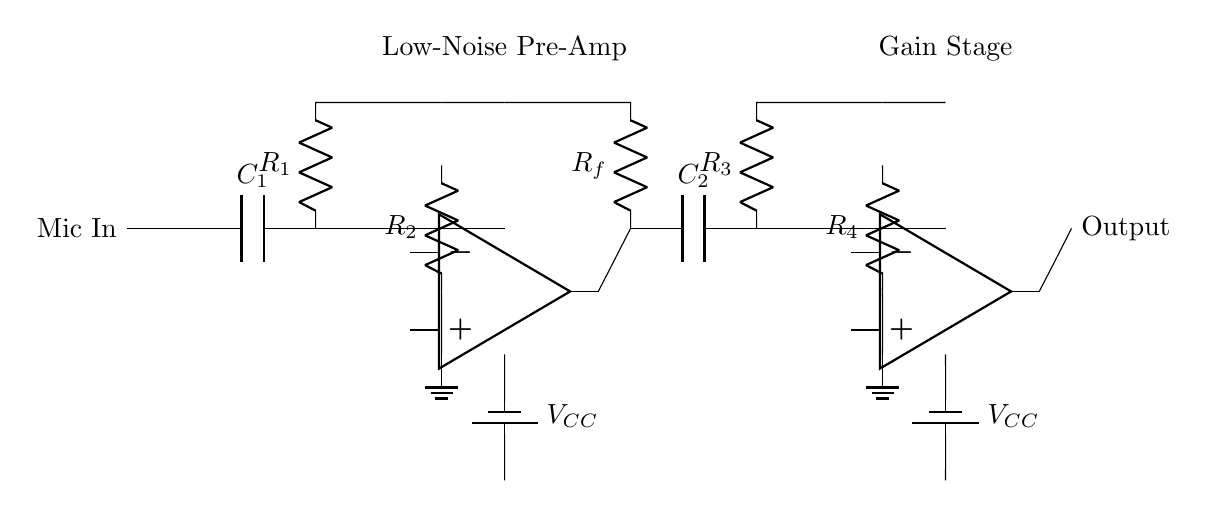What is the input component of the circuit? The input component of the circuit is a microphone, labeled "Mic In". It is the first part through which the audio signal enters the pre-amplifier circuit.
Answer: Microphone How many operational amplifiers are used in this circuit? There are two operational amplifiers in this circuit, labeled as "op amp". They are used in different stages to amplify the signal.
Answer: Two What type of circuit is this? This circuit is a low-noise pre-amplifier designed to enhance the quality of the microphone signal before further processing. It aims to reduce noise during voice transmissions.
Answer: Low-noise pre-amplifier What are the resistors labeled in the circuit? The resistors in the circuit are labeled as R1, R2, R3, and R4, serving different functions in the gain and feedback system of the amplifier.
Answer: R1, R2, R3, R4 What is the function of capacitor C1? Capacitor C1 acts as a coupling capacitor, allowing AC signals from the microphone to pass while blocking DC components, thus ensuring the input signal stays within the desired frequency range.
Answer: Coupling What happens when the gain stage is activated? When the gain stage is activated by the operational amplifier, the output signal is amplified, increasing its voltage and making it stronger for clearer transmission in voice chat systems.
Answer: Amplified output How are the power supplies indicated in the diagram? The power supplies for the operational amplifiers are indicated by two batteries labeled "VCC" at the bottom of each op-amp section, providing the necessary voltage for operation.
Answer: VCC 